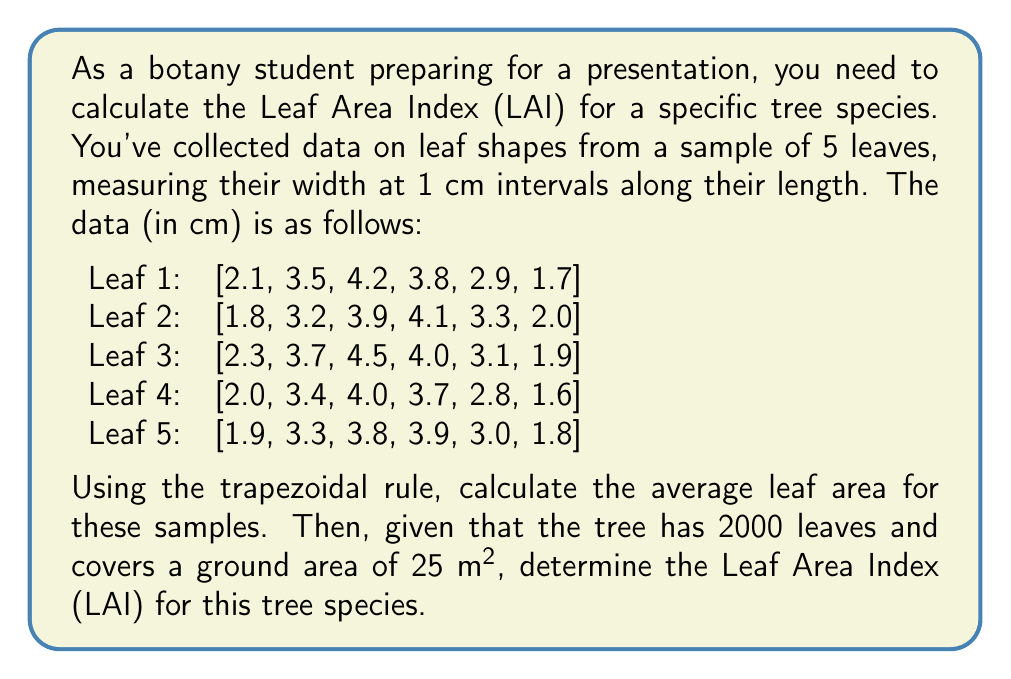Can you solve this math problem? To solve this problem, we'll follow these steps:

1. Calculate the area of each leaf using the trapezoidal rule
2. Find the average leaf area
3. Calculate the total leaf area for the tree
4. Compute the Leaf Area Index (LAI)

Step 1: Calculate the area of each leaf using the trapezoidal rule

The trapezoidal rule for numerical integration is given by:

$$ \int_{a}^{b} f(x) dx \approx \frac{h}{2} \left[ f(x_0) + 2f(x_1) + 2f(x_2) + ... + 2f(x_{n-1}) + f(x_n) \right] $$

where $h$ is the interval between measurements (in this case, 1 cm).

For each leaf:

$$ A = \frac{1}{2} \left[ w_0 + 2w_1 + 2w_2 + 2w_3 + 2w_4 + w_5 \right] $$

Leaf 1: $A_1 = \frac{1}{2} [2.1 + 2(3.5 + 4.2 + 3.8 + 2.9) + 1.7] = 13.05$ cm²
Leaf 2: $A_2 = \frac{1}{2} [1.8 + 2(3.2 + 3.9 + 4.1 + 3.3) + 2.0] = 12.75$ cm²
Leaf 3: $A_3 = \frac{1}{2} [2.3 + 2(3.7 + 4.5 + 4.0 + 3.1) + 1.9] = 13.65$ cm²
Leaf 4: $A_4 = \frac{1}{2} [2.0 + 2(3.4 + 4.0 + 3.7 + 2.8) + 1.6] = 12.35$ cm²
Leaf 5: $A_5 = \frac{1}{2} [1.9 + 2(3.3 + 3.8 + 3.9 + 3.0) + 1.8] = 12.45$ cm²

Step 2: Find the average leaf area

$$ A_{avg} = \frac{A_1 + A_2 + A_3 + A_4 + A_5}{5} = \frac{13.05 + 12.75 + 13.65 + 12.35 + 12.45}{5} = 12.85 \text{ cm²} $$

Step 3: Calculate the total leaf area for the tree

Total leaf area = Number of leaves × Average leaf area
$$ A_{total} = 2000 \times 12.85 \text{ cm²} = 25,700 \text{ cm²} = 2.57 \text{ m²} $$

Step 4: Compute the Leaf Area Index (LAI)

LAI is defined as the total one-sided leaf area per unit ground area:

$$ LAI = \frac{\text{Total leaf area}}{\text{Ground area}} $$

$$ LAI = \frac{2.57 \text{ m²}}{25 \text{ m²}} = 0.1028 $$
Answer: The Leaf Area Index (LAI) for this tree species is approximately 0.1028. 